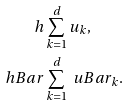<formula> <loc_0><loc_0><loc_500><loc_500>h & \sum _ { k = 1 } ^ { d } u _ { k } , \\ \ h B a r & \sum _ { k = 1 } ^ { d } \ u B a r _ { k } .</formula> 